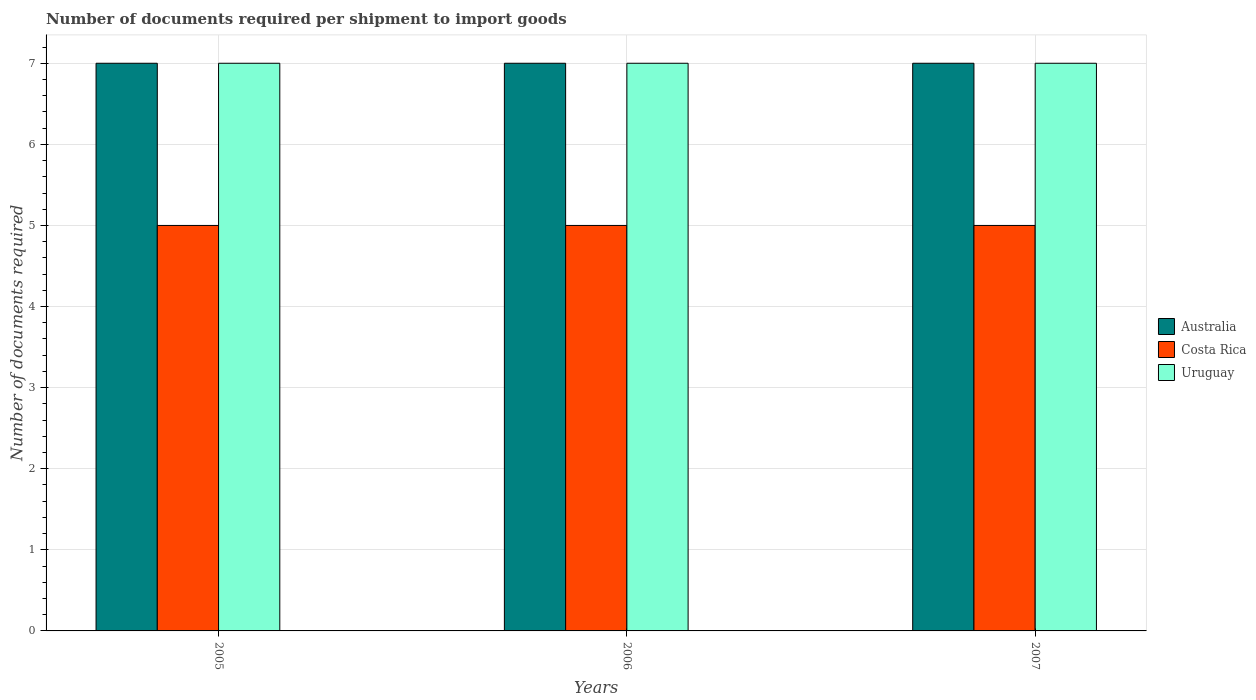How many different coloured bars are there?
Your response must be concise. 3. How many bars are there on the 1st tick from the right?
Provide a short and direct response. 3. What is the label of the 3rd group of bars from the left?
Provide a succinct answer. 2007. What is the number of documents required per shipment to import goods in Australia in 2007?
Provide a succinct answer. 7. Across all years, what is the maximum number of documents required per shipment to import goods in Costa Rica?
Provide a succinct answer. 5. Across all years, what is the minimum number of documents required per shipment to import goods in Australia?
Ensure brevity in your answer.  7. In which year was the number of documents required per shipment to import goods in Uruguay minimum?
Your answer should be compact. 2005. What is the total number of documents required per shipment to import goods in Australia in the graph?
Offer a terse response. 21. What is the difference between the number of documents required per shipment to import goods in Uruguay in 2005 and the number of documents required per shipment to import goods in Costa Rica in 2006?
Your response must be concise. 2. In the year 2005, what is the difference between the number of documents required per shipment to import goods in Uruguay and number of documents required per shipment to import goods in Costa Rica?
Provide a succinct answer. 2. In how many years, is the number of documents required per shipment to import goods in Australia greater than 7?
Ensure brevity in your answer.  0. What is the ratio of the number of documents required per shipment to import goods in Australia in 2006 to that in 2007?
Provide a short and direct response. 1. What is the difference between the highest and the second highest number of documents required per shipment to import goods in Australia?
Provide a succinct answer. 0. What is the difference between the highest and the lowest number of documents required per shipment to import goods in Costa Rica?
Ensure brevity in your answer.  0. What does the 2nd bar from the left in 2005 represents?
Your answer should be very brief. Costa Rica. What does the 1st bar from the right in 2007 represents?
Offer a terse response. Uruguay. Are all the bars in the graph horizontal?
Make the answer very short. No. How many years are there in the graph?
Keep it short and to the point. 3. Are the values on the major ticks of Y-axis written in scientific E-notation?
Your answer should be very brief. No. Where does the legend appear in the graph?
Give a very brief answer. Center right. How are the legend labels stacked?
Keep it short and to the point. Vertical. What is the title of the graph?
Give a very brief answer. Number of documents required per shipment to import goods. Does "Germany" appear as one of the legend labels in the graph?
Offer a very short reply. No. What is the label or title of the Y-axis?
Your answer should be compact. Number of documents required. What is the Number of documents required in Australia in 2005?
Make the answer very short. 7. What is the Number of documents required in Uruguay in 2006?
Provide a short and direct response. 7. Across all years, what is the minimum Number of documents required of Australia?
Provide a succinct answer. 7. What is the total Number of documents required of Australia in the graph?
Your answer should be very brief. 21. What is the total Number of documents required of Costa Rica in the graph?
Ensure brevity in your answer.  15. What is the difference between the Number of documents required of Australia in 2005 and that in 2006?
Keep it short and to the point. 0. What is the difference between the Number of documents required in Uruguay in 2005 and that in 2006?
Offer a very short reply. 0. What is the difference between the Number of documents required of Australia in 2005 and that in 2007?
Provide a succinct answer. 0. What is the difference between the Number of documents required of Costa Rica in 2005 and that in 2007?
Provide a short and direct response. 0. What is the difference between the Number of documents required of Uruguay in 2005 and that in 2007?
Keep it short and to the point. 0. What is the difference between the Number of documents required of Uruguay in 2006 and that in 2007?
Keep it short and to the point. 0. What is the difference between the Number of documents required of Australia in 2005 and the Number of documents required of Uruguay in 2006?
Your answer should be very brief. 0. What is the difference between the Number of documents required of Costa Rica in 2005 and the Number of documents required of Uruguay in 2006?
Keep it short and to the point. -2. What is the difference between the Number of documents required in Australia in 2005 and the Number of documents required in Costa Rica in 2007?
Give a very brief answer. 2. What is the difference between the Number of documents required in Australia in 2005 and the Number of documents required in Uruguay in 2007?
Provide a short and direct response. 0. What is the difference between the Number of documents required of Costa Rica in 2005 and the Number of documents required of Uruguay in 2007?
Offer a very short reply. -2. What is the difference between the Number of documents required in Australia in 2006 and the Number of documents required in Costa Rica in 2007?
Your answer should be very brief. 2. What is the difference between the Number of documents required in Australia in 2006 and the Number of documents required in Uruguay in 2007?
Offer a very short reply. 0. In the year 2005, what is the difference between the Number of documents required of Australia and Number of documents required of Costa Rica?
Your answer should be very brief. 2. In the year 2005, what is the difference between the Number of documents required in Costa Rica and Number of documents required in Uruguay?
Your answer should be compact. -2. In the year 2006, what is the difference between the Number of documents required in Australia and Number of documents required in Costa Rica?
Offer a terse response. 2. In the year 2006, what is the difference between the Number of documents required of Australia and Number of documents required of Uruguay?
Provide a succinct answer. 0. In the year 2006, what is the difference between the Number of documents required in Costa Rica and Number of documents required in Uruguay?
Ensure brevity in your answer.  -2. What is the ratio of the Number of documents required of Australia in 2005 to that in 2006?
Offer a very short reply. 1. What is the ratio of the Number of documents required in Australia in 2005 to that in 2007?
Offer a terse response. 1. What is the ratio of the Number of documents required in Australia in 2006 to that in 2007?
Your response must be concise. 1. What is the ratio of the Number of documents required in Costa Rica in 2006 to that in 2007?
Offer a very short reply. 1. What is the ratio of the Number of documents required in Uruguay in 2006 to that in 2007?
Provide a short and direct response. 1. What is the difference between the highest and the second highest Number of documents required in Australia?
Your response must be concise. 0. What is the difference between the highest and the lowest Number of documents required in Australia?
Offer a terse response. 0. What is the difference between the highest and the lowest Number of documents required in Costa Rica?
Ensure brevity in your answer.  0. 